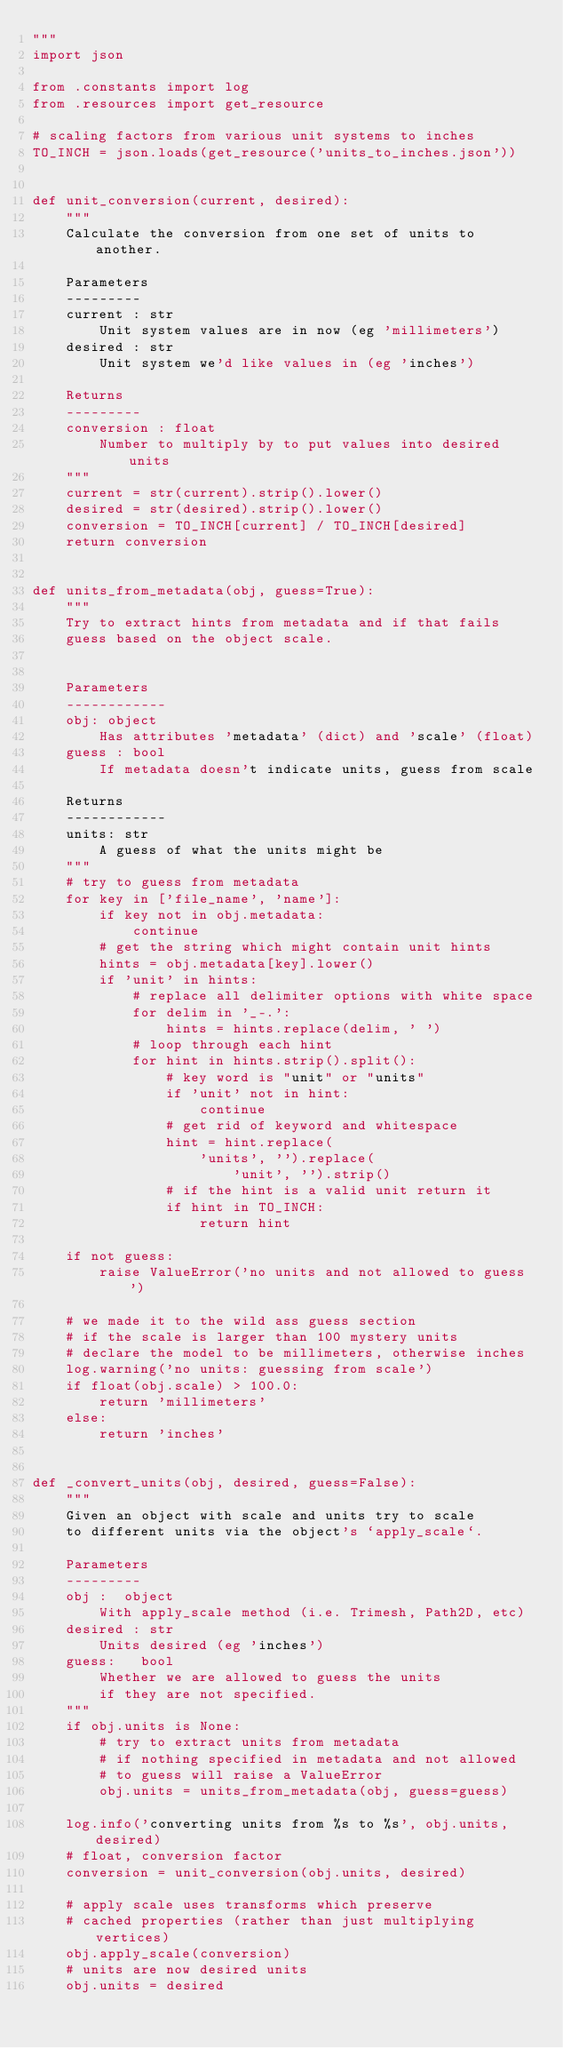Convert code to text. <code><loc_0><loc_0><loc_500><loc_500><_Python_>"""
import json

from .constants import log
from .resources import get_resource

# scaling factors from various unit systems to inches
TO_INCH = json.loads(get_resource('units_to_inches.json'))


def unit_conversion(current, desired):
    """
    Calculate the conversion from one set of units to another.

    Parameters
    ---------
    current : str
        Unit system values are in now (eg 'millimeters')
    desired : str
        Unit system we'd like values in (eg 'inches')

    Returns
    ---------
    conversion : float
        Number to multiply by to put values into desired units
    """
    current = str(current).strip().lower()
    desired = str(desired).strip().lower()
    conversion = TO_INCH[current] / TO_INCH[desired]
    return conversion


def units_from_metadata(obj, guess=True):
    """
    Try to extract hints from metadata and if that fails
    guess based on the object scale.


    Parameters
    ------------
    obj: object
        Has attributes 'metadata' (dict) and 'scale' (float)
    guess : bool
        If metadata doesn't indicate units, guess from scale

    Returns
    ------------
    units: str
        A guess of what the units might be
    """
    # try to guess from metadata
    for key in ['file_name', 'name']:
        if key not in obj.metadata:
            continue
        # get the string which might contain unit hints
        hints = obj.metadata[key].lower()
        if 'unit' in hints:
            # replace all delimiter options with white space
            for delim in '_-.':
                hints = hints.replace(delim, ' ')
            # loop through each hint
            for hint in hints.strip().split():
                # key word is "unit" or "units"
                if 'unit' not in hint:
                    continue
                # get rid of keyword and whitespace
                hint = hint.replace(
                    'units', '').replace(
                        'unit', '').strip()
                # if the hint is a valid unit return it
                if hint in TO_INCH:
                    return hint

    if not guess:
        raise ValueError('no units and not allowed to guess')

    # we made it to the wild ass guess section
    # if the scale is larger than 100 mystery units
    # declare the model to be millimeters, otherwise inches
    log.warning('no units: guessing from scale')
    if float(obj.scale) > 100.0:
        return 'millimeters'
    else:
        return 'inches'


def _convert_units(obj, desired, guess=False):
    """
    Given an object with scale and units try to scale
    to different units via the object's `apply_scale`.

    Parameters
    ---------
    obj :  object
        With apply_scale method (i.e. Trimesh, Path2D, etc)
    desired : str
        Units desired (eg 'inches')
    guess:   bool
        Whether we are allowed to guess the units
        if they are not specified.
    """
    if obj.units is None:
        # try to extract units from metadata
        # if nothing specified in metadata and not allowed
        # to guess will raise a ValueError
        obj.units = units_from_metadata(obj, guess=guess)

    log.info('converting units from %s to %s', obj.units, desired)
    # float, conversion factor
    conversion = unit_conversion(obj.units, desired)

    # apply scale uses transforms which preserve
    # cached properties (rather than just multiplying vertices)
    obj.apply_scale(conversion)
    # units are now desired units
    obj.units = desired
</code> 